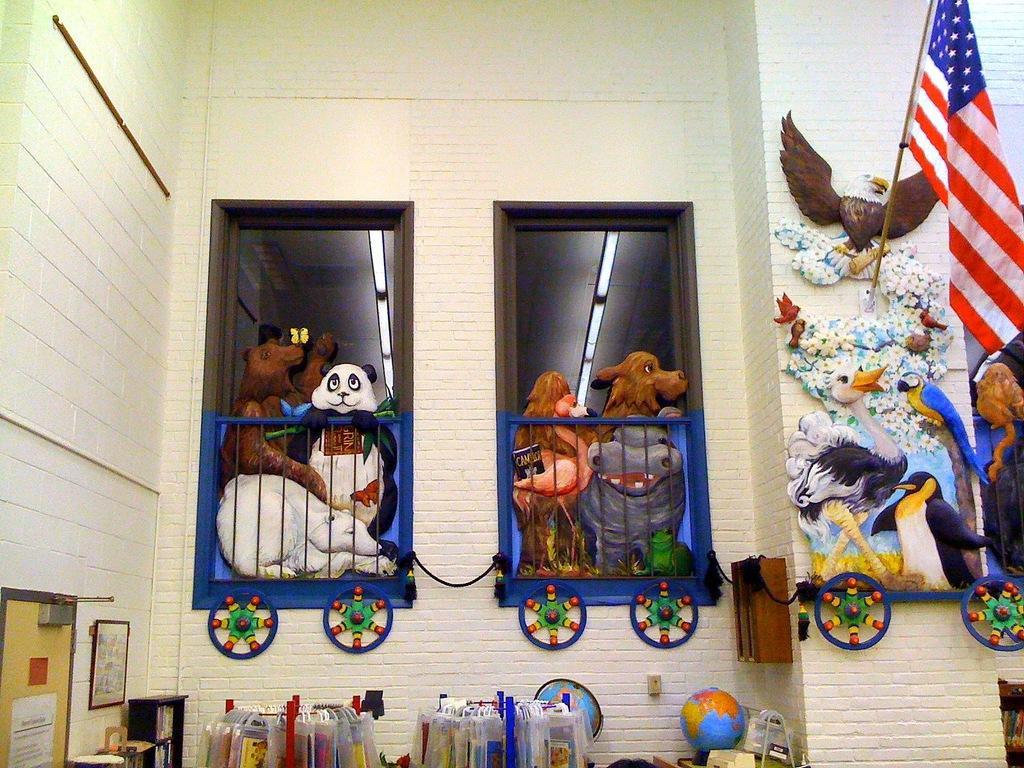In one or two sentences, can you explain what this image depicts? In this image I can see a flag which is red, white and blue in color, the cream colored wall, few wheels attached to the wall, two globes, few bags hanged to the metal rods and few soft toys which are in the shape of animals which are white, black, brown and pink in color, few lights, the ceiling and few other objects. 